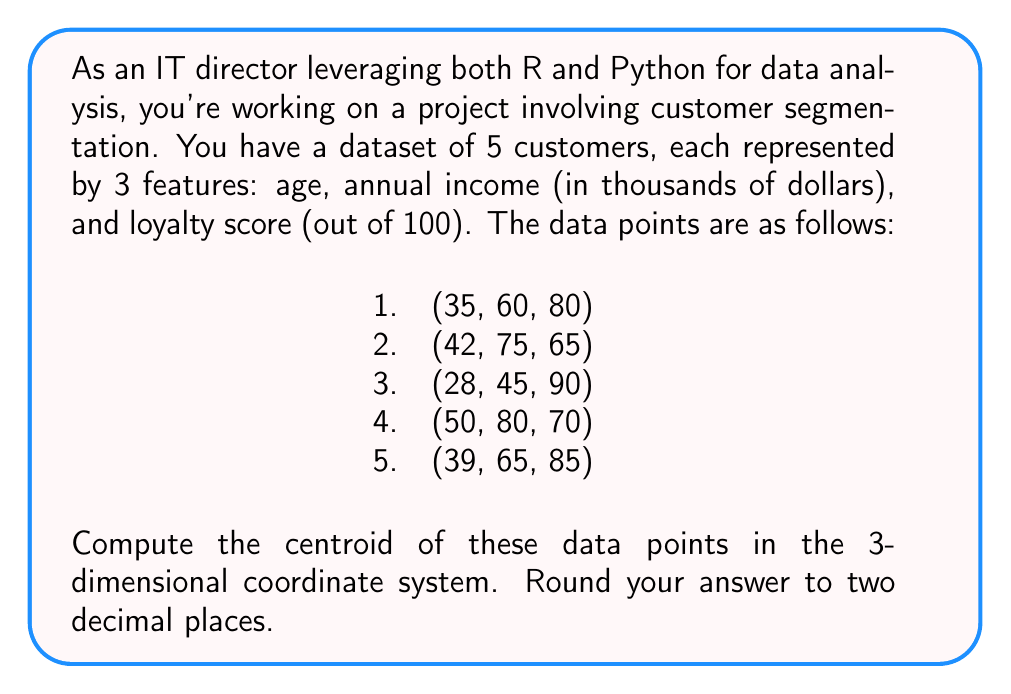Solve this math problem. To compute the centroid of a set of data points in a multidimensional coordinate system, we need to calculate the average of each dimension separately. The centroid is then represented by these average values.

Let's break it down step by step:

1. Separate the coordinates into their respective dimensions:
   x (age): 35, 42, 28, 50, 39
   y (income): 60, 75, 45, 80, 65
   z (loyalty): 80, 65, 90, 70, 85

2. Calculate the average for each dimension:

   For x (age):
   $$\bar{x} = \frac{35 + 42 + 28 + 50 + 39}{5} = \frac{194}{5} = 38.8$$

   For y (income):
   $$\bar{y} = \frac{60 + 75 + 45 + 80 + 65}{5} = \frac{325}{5} = 65$$

   For z (loyalty):
   $$\bar{z} = \frac{80 + 65 + 90 + 70 + 85}{5} = \frac{390}{5} = 78$$

3. The centroid is the point $(\bar{x}, \bar{y}, \bar{z})$.

4. Rounding each coordinate to two decimal places:
   x: 38.80
   y: 65.00
   z: 78.00

Therefore, the centroid of the given data points is (38.80, 65.00, 78.00).
Answer: (38.80, 65.00, 78.00) 